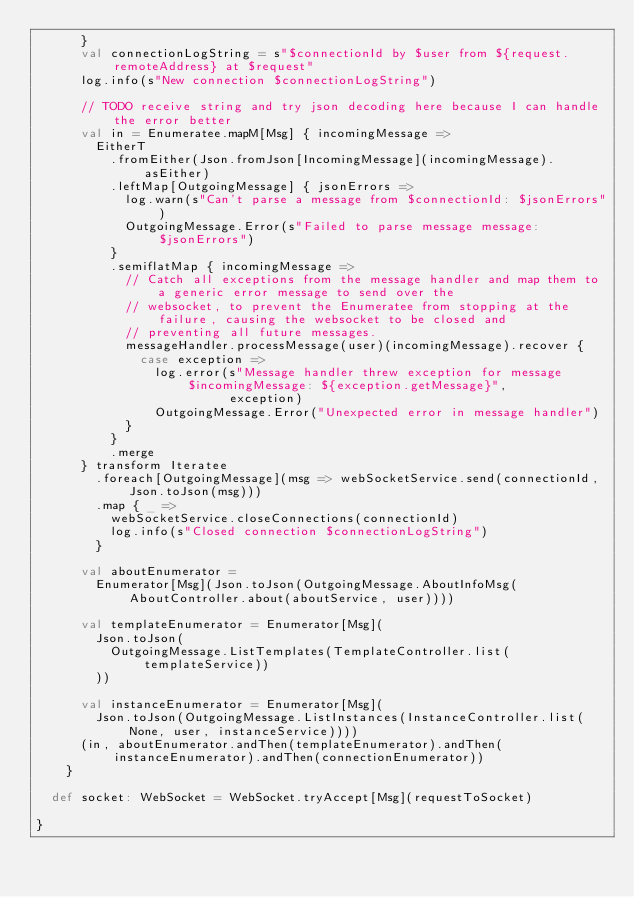Convert code to text. <code><loc_0><loc_0><loc_500><loc_500><_Scala_>      }
      val connectionLogString = s"$connectionId by $user from ${request.remoteAddress} at $request"
      log.info(s"New connection $connectionLogString")

      // TODO receive string and try json decoding here because I can handle the error better
      val in = Enumeratee.mapM[Msg] { incomingMessage =>
        EitherT
          .fromEither(Json.fromJson[IncomingMessage](incomingMessage).asEither)
          .leftMap[OutgoingMessage] { jsonErrors =>
            log.warn(s"Can't parse a message from $connectionId: $jsonErrors")
            OutgoingMessage.Error(s"Failed to parse message message: $jsonErrors")
          }
          .semiflatMap { incomingMessage =>
            // Catch all exceptions from the message handler and map them to a generic error message to send over the
            // websocket, to prevent the Enumeratee from stopping at the failure, causing the websocket to be closed and
            // preventing all future messages.
            messageHandler.processMessage(user)(incomingMessage).recover {
              case exception =>
                log.error(s"Message handler threw exception for message $incomingMessage: ${exception.getMessage}",
                          exception)
                OutgoingMessage.Error("Unexpected error in message handler")
            }
          }
          .merge
      } transform Iteratee
        .foreach[OutgoingMessage](msg => webSocketService.send(connectionId, Json.toJson(msg)))
        .map { _ =>
          webSocketService.closeConnections(connectionId)
          log.info(s"Closed connection $connectionLogString")
        }

      val aboutEnumerator =
        Enumerator[Msg](Json.toJson(OutgoingMessage.AboutInfoMsg(AboutController.about(aboutService, user))))

      val templateEnumerator = Enumerator[Msg](
        Json.toJson(
          OutgoingMessage.ListTemplates(TemplateController.list(templateService))
        ))

      val instanceEnumerator = Enumerator[Msg](
        Json.toJson(OutgoingMessage.ListInstances(InstanceController.list(None, user, instanceService))))
      (in, aboutEnumerator.andThen(templateEnumerator).andThen(instanceEnumerator).andThen(connectionEnumerator))
    }

  def socket: WebSocket = WebSocket.tryAccept[Msg](requestToSocket)

}
</code> 